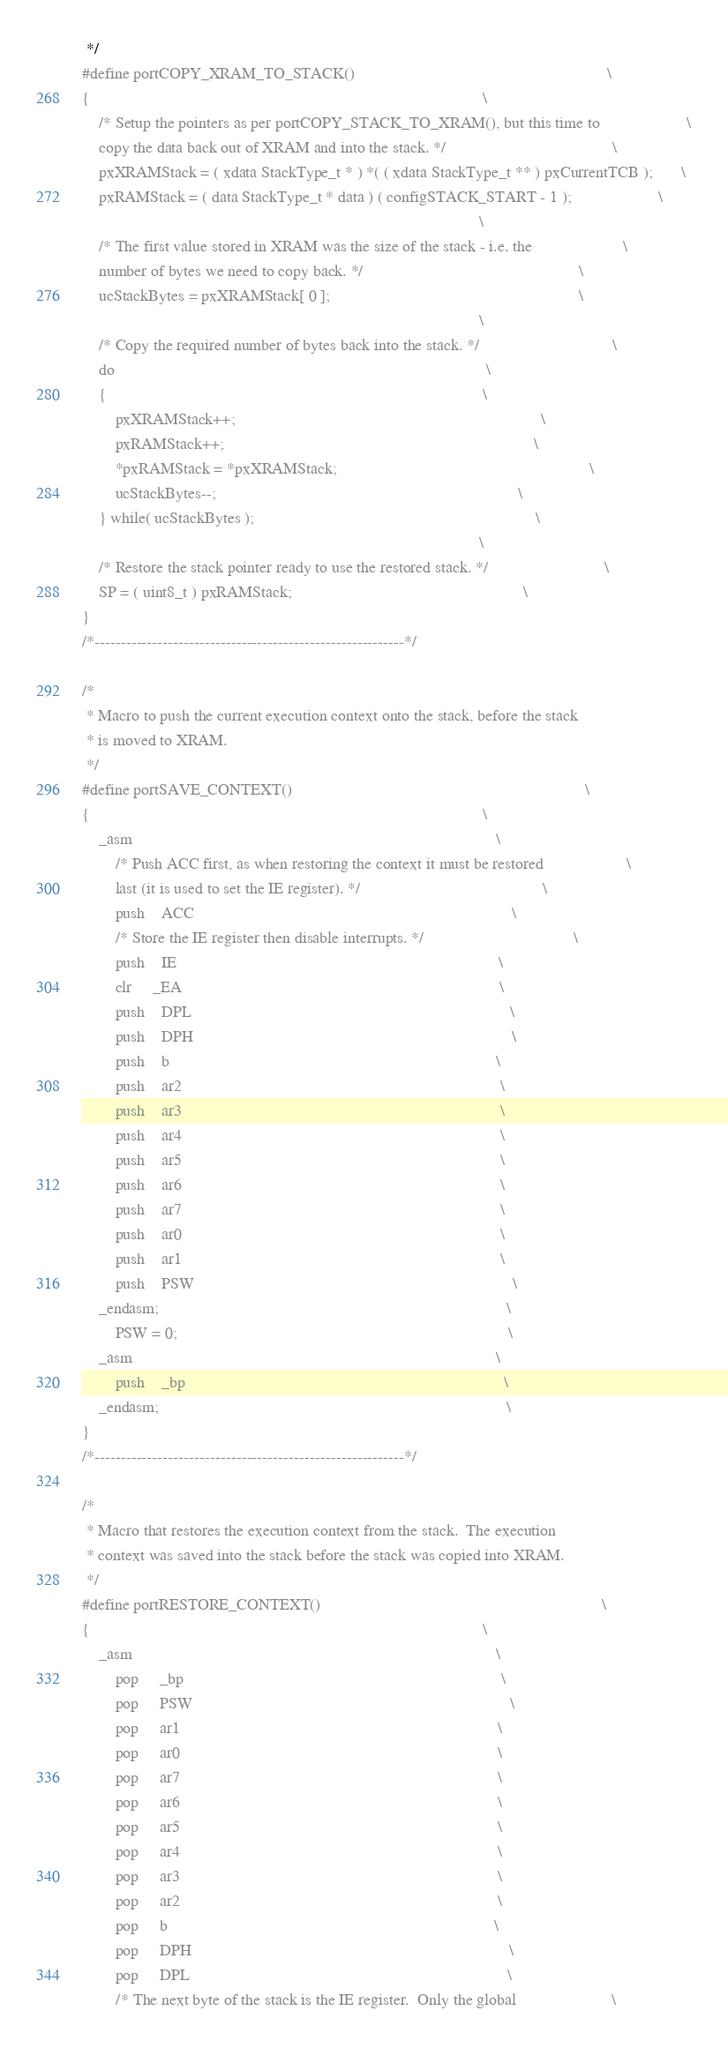Convert code to text. <code><loc_0><loc_0><loc_500><loc_500><_C_> */
#define portCOPY_XRAM_TO_STACK()																\
{																								\
	/* Setup the pointers as per portCOPY_STACK_TO_XRAM(), but this time to						\
	copy the data back out of XRAM and into the stack. */										\
	pxXRAMStack = ( xdata StackType_t * ) *( ( xdata StackType_t ** ) pxCurrentTCB );		\
	pxRAMStack = ( data StackType_t * data ) ( configSTACK_START - 1 );						\
																								\
	/* The first value stored in XRAM was the size of the stack - i.e. the						\
	number of bytes we need to copy back. */													\
	ucStackBytes = pxXRAMStack[ 0 ];															\
																								\
	/* Copy the required number of bytes back into the stack. */								\
	do																							\
	{																							\
		pxXRAMStack++;																			\
		pxRAMStack++;																			\
		*pxRAMStack = *pxXRAMStack;																\
		ucStackBytes--;																			\
	} while( ucStackBytes );																	\
																								\
	/* Restore the stack pointer ready to use the restored stack. */							\
	SP = ( uint8_t ) pxRAMStack;														\
}
/*-----------------------------------------------------------*/

/*
 * Macro to push the current execution context onto the stack, before the stack 
 * is moved to XRAM. 
 */
#define portSAVE_CONTEXT()																		\
{																								\
	_asm																						\
		/* Push ACC first, as when restoring the context it must be restored					\
		last (it is used to set the IE register). */											\
		push	ACC																				\
		/* Store the IE register then disable interrupts. */									\
		push	IE																				\
		clr		_EA																				\
		push	DPL																				\
		push	DPH																				\
		push	b																				\
		push	ar2																				\
		push	ar3																				\
		push	ar4																				\
		push	ar5																				\
		push	ar6																				\
		push	ar7																				\
		push	ar0																				\
		push	ar1																				\
		push	PSW																				\
	_endasm;																					\
		PSW = 0;																				\
	_asm																						\
		push	_bp																				\
	_endasm;																					\
}
/*-----------------------------------------------------------*/

/*
 * Macro that restores the execution context from the stack.  The execution 
 * context was saved into the stack before the stack was copied into XRAM.
 */
#define portRESTORE_CONTEXT()																	\
{																								\
	_asm																						\
		pop		_bp																				\
		pop		PSW																				\
		pop		ar1																				\
		pop		ar0																				\
		pop		ar7																				\
		pop		ar6																				\
		pop		ar5																				\
		pop		ar4																				\
		pop		ar3																				\
		pop		ar2																				\
		pop		b																				\
		pop		DPH																				\
		pop		DPL																				\
		/* The next byte of the stack is the IE register.  Only the global						\</code> 